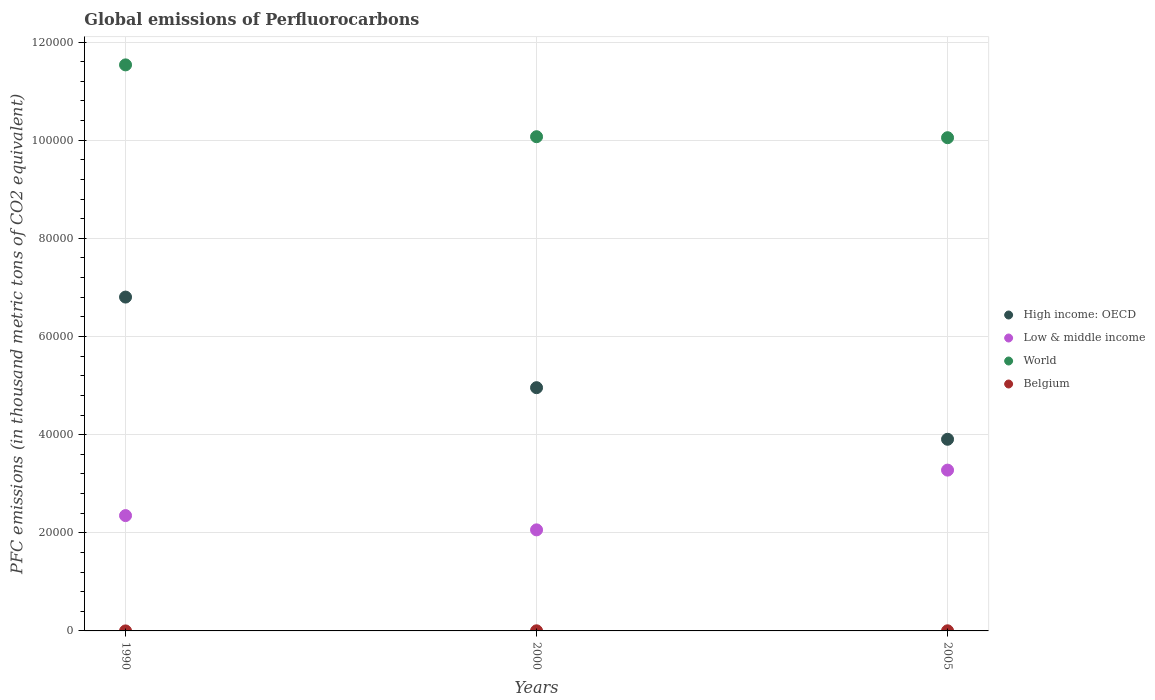How many different coloured dotlines are there?
Offer a terse response. 4. What is the global emissions of Perfluorocarbons in Low & middle income in 1990?
Give a very brief answer. 2.35e+04. Across all years, what is the maximum global emissions of Perfluorocarbons in World?
Your response must be concise. 1.15e+05. Across all years, what is the minimum global emissions of Perfluorocarbons in Belgium?
Keep it short and to the point. 2.9. What is the total global emissions of Perfluorocarbons in Belgium in the graph?
Your answer should be compact. 53.8. What is the difference between the global emissions of Perfluorocarbons in High income: OECD in 1990 and that in 2000?
Provide a succinct answer. 1.85e+04. What is the difference between the global emissions of Perfluorocarbons in World in 1990 and the global emissions of Perfluorocarbons in Belgium in 2000?
Make the answer very short. 1.15e+05. What is the average global emissions of Perfluorocarbons in High income: OECD per year?
Make the answer very short. 5.22e+04. In the year 1990, what is the difference between the global emissions of Perfluorocarbons in High income: OECD and global emissions of Perfluorocarbons in Low & middle income?
Give a very brief answer. 4.45e+04. What is the ratio of the global emissions of Perfluorocarbons in Belgium in 1990 to that in 2000?
Make the answer very short. 0.12. Is the global emissions of Perfluorocarbons in High income: OECD in 1990 less than that in 2000?
Ensure brevity in your answer.  No. What is the difference between the highest and the second highest global emissions of Perfluorocarbons in High income: OECD?
Make the answer very short. 1.85e+04. What is the difference between the highest and the lowest global emissions of Perfluorocarbons in Belgium?
Your response must be concise. 22.8. In how many years, is the global emissions of Perfluorocarbons in Low & middle income greater than the average global emissions of Perfluorocarbons in Low & middle income taken over all years?
Keep it short and to the point. 1. Does the global emissions of Perfluorocarbons in High income: OECD monotonically increase over the years?
Give a very brief answer. No. Is the global emissions of Perfluorocarbons in Low & middle income strictly greater than the global emissions of Perfluorocarbons in Belgium over the years?
Offer a very short reply. Yes. Is the global emissions of Perfluorocarbons in Low & middle income strictly less than the global emissions of Perfluorocarbons in High income: OECD over the years?
Ensure brevity in your answer.  Yes. How many dotlines are there?
Your answer should be compact. 4. How many years are there in the graph?
Keep it short and to the point. 3. What is the difference between two consecutive major ticks on the Y-axis?
Ensure brevity in your answer.  2.00e+04. Are the values on the major ticks of Y-axis written in scientific E-notation?
Give a very brief answer. No. Does the graph contain any zero values?
Provide a succinct answer. No. Where does the legend appear in the graph?
Give a very brief answer. Center right. How are the legend labels stacked?
Your answer should be very brief. Vertical. What is the title of the graph?
Provide a succinct answer. Global emissions of Perfluorocarbons. What is the label or title of the X-axis?
Provide a short and direct response. Years. What is the label or title of the Y-axis?
Offer a very short reply. PFC emissions (in thousand metric tons of CO2 equivalent). What is the PFC emissions (in thousand metric tons of CO2 equivalent) in High income: OECD in 1990?
Offer a terse response. 6.80e+04. What is the PFC emissions (in thousand metric tons of CO2 equivalent) of Low & middle income in 1990?
Provide a succinct answer. 2.35e+04. What is the PFC emissions (in thousand metric tons of CO2 equivalent) in World in 1990?
Offer a very short reply. 1.15e+05. What is the PFC emissions (in thousand metric tons of CO2 equivalent) of High income: OECD in 2000?
Provide a succinct answer. 4.96e+04. What is the PFC emissions (in thousand metric tons of CO2 equivalent) of Low & middle income in 2000?
Your answer should be very brief. 2.06e+04. What is the PFC emissions (in thousand metric tons of CO2 equivalent) in World in 2000?
Your response must be concise. 1.01e+05. What is the PFC emissions (in thousand metric tons of CO2 equivalent) of Belgium in 2000?
Your response must be concise. 25.2. What is the PFC emissions (in thousand metric tons of CO2 equivalent) in High income: OECD in 2005?
Your response must be concise. 3.91e+04. What is the PFC emissions (in thousand metric tons of CO2 equivalent) in Low & middle income in 2005?
Keep it short and to the point. 3.28e+04. What is the PFC emissions (in thousand metric tons of CO2 equivalent) of World in 2005?
Ensure brevity in your answer.  1.01e+05. What is the PFC emissions (in thousand metric tons of CO2 equivalent) in Belgium in 2005?
Provide a short and direct response. 25.7. Across all years, what is the maximum PFC emissions (in thousand metric tons of CO2 equivalent) of High income: OECD?
Provide a short and direct response. 6.80e+04. Across all years, what is the maximum PFC emissions (in thousand metric tons of CO2 equivalent) in Low & middle income?
Ensure brevity in your answer.  3.28e+04. Across all years, what is the maximum PFC emissions (in thousand metric tons of CO2 equivalent) of World?
Offer a very short reply. 1.15e+05. Across all years, what is the maximum PFC emissions (in thousand metric tons of CO2 equivalent) of Belgium?
Offer a terse response. 25.7. Across all years, what is the minimum PFC emissions (in thousand metric tons of CO2 equivalent) in High income: OECD?
Provide a succinct answer. 3.91e+04. Across all years, what is the minimum PFC emissions (in thousand metric tons of CO2 equivalent) in Low & middle income?
Offer a terse response. 2.06e+04. Across all years, what is the minimum PFC emissions (in thousand metric tons of CO2 equivalent) in World?
Keep it short and to the point. 1.01e+05. Across all years, what is the minimum PFC emissions (in thousand metric tons of CO2 equivalent) of Belgium?
Give a very brief answer. 2.9. What is the total PFC emissions (in thousand metric tons of CO2 equivalent) of High income: OECD in the graph?
Make the answer very short. 1.57e+05. What is the total PFC emissions (in thousand metric tons of CO2 equivalent) in Low & middle income in the graph?
Give a very brief answer. 7.69e+04. What is the total PFC emissions (in thousand metric tons of CO2 equivalent) in World in the graph?
Provide a succinct answer. 3.17e+05. What is the total PFC emissions (in thousand metric tons of CO2 equivalent) in Belgium in the graph?
Provide a short and direct response. 53.8. What is the difference between the PFC emissions (in thousand metric tons of CO2 equivalent) in High income: OECD in 1990 and that in 2000?
Your answer should be very brief. 1.85e+04. What is the difference between the PFC emissions (in thousand metric tons of CO2 equivalent) of Low & middle income in 1990 and that in 2000?
Your answer should be very brief. 2906.6. What is the difference between the PFC emissions (in thousand metric tons of CO2 equivalent) in World in 1990 and that in 2000?
Your response must be concise. 1.46e+04. What is the difference between the PFC emissions (in thousand metric tons of CO2 equivalent) of Belgium in 1990 and that in 2000?
Keep it short and to the point. -22.3. What is the difference between the PFC emissions (in thousand metric tons of CO2 equivalent) of High income: OECD in 1990 and that in 2005?
Give a very brief answer. 2.90e+04. What is the difference between the PFC emissions (in thousand metric tons of CO2 equivalent) in Low & middle income in 1990 and that in 2005?
Offer a very short reply. -9268.08. What is the difference between the PFC emissions (in thousand metric tons of CO2 equivalent) of World in 1990 and that in 2005?
Your answer should be very brief. 1.48e+04. What is the difference between the PFC emissions (in thousand metric tons of CO2 equivalent) of Belgium in 1990 and that in 2005?
Offer a terse response. -22.8. What is the difference between the PFC emissions (in thousand metric tons of CO2 equivalent) in High income: OECD in 2000 and that in 2005?
Your answer should be very brief. 1.05e+04. What is the difference between the PFC emissions (in thousand metric tons of CO2 equivalent) in Low & middle income in 2000 and that in 2005?
Ensure brevity in your answer.  -1.22e+04. What is the difference between the PFC emissions (in thousand metric tons of CO2 equivalent) in World in 2000 and that in 2005?
Provide a succinct answer. 203. What is the difference between the PFC emissions (in thousand metric tons of CO2 equivalent) of Belgium in 2000 and that in 2005?
Your response must be concise. -0.5. What is the difference between the PFC emissions (in thousand metric tons of CO2 equivalent) of High income: OECD in 1990 and the PFC emissions (in thousand metric tons of CO2 equivalent) of Low & middle income in 2000?
Make the answer very short. 4.74e+04. What is the difference between the PFC emissions (in thousand metric tons of CO2 equivalent) in High income: OECD in 1990 and the PFC emissions (in thousand metric tons of CO2 equivalent) in World in 2000?
Offer a very short reply. -3.27e+04. What is the difference between the PFC emissions (in thousand metric tons of CO2 equivalent) of High income: OECD in 1990 and the PFC emissions (in thousand metric tons of CO2 equivalent) of Belgium in 2000?
Your answer should be very brief. 6.80e+04. What is the difference between the PFC emissions (in thousand metric tons of CO2 equivalent) of Low & middle income in 1990 and the PFC emissions (in thousand metric tons of CO2 equivalent) of World in 2000?
Offer a very short reply. -7.72e+04. What is the difference between the PFC emissions (in thousand metric tons of CO2 equivalent) of Low & middle income in 1990 and the PFC emissions (in thousand metric tons of CO2 equivalent) of Belgium in 2000?
Offer a terse response. 2.35e+04. What is the difference between the PFC emissions (in thousand metric tons of CO2 equivalent) in World in 1990 and the PFC emissions (in thousand metric tons of CO2 equivalent) in Belgium in 2000?
Keep it short and to the point. 1.15e+05. What is the difference between the PFC emissions (in thousand metric tons of CO2 equivalent) in High income: OECD in 1990 and the PFC emissions (in thousand metric tons of CO2 equivalent) in Low & middle income in 2005?
Your answer should be compact. 3.53e+04. What is the difference between the PFC emissions (in thousand metric tons of CO2 equivalent) in High income: OECD in 1990 and the PFC emissions (in thousand metric tons of CO2 equivalent) in World in 2005?
Provide a short and direct response. -3.25e+04. What is the difference between the PFC emissions (in thousand metric tons of CO2 equivalent) of High income: OECD in 1990 and the PFC emissions (in thousand metric tons of CO2 equivalent) of Belgium in 2005?
Provide a short and direct response. 6.80e+04. What is the difference between the PFC emissions (in thousand metric tons of CO2 equivalent) of Low & middle income in 1990 and the PFC emissions (in thousand metric tons of CO2 equivalent) of World in 2005?
Keep it short and to the point. -7.70e+04. What is the difference between the PFC emissions (in thousand metric tons of CO2 equivalent) of Low & middle income in 1990 and the PFC emissions (in thousand metric tons of CO2 equivalent) of Belgium in 2005?
Provide a succinct answer. 2.35e+04. What is the difference between the PFC emissions (in thousand metric tons of CO2 equivalent) of World in 1990 and the PFC emissions (in thousand metric tons of CO2 equivalent) of Belgium in 2005?
Your response must be concise. 1.15e+05. What is the difference between the PFC emissions (in thousand metric tons of CO2 equivalent) of High income: OECD in 2000 and the PFC emissions (in thousand metric tons of CO2 equivalent) of Low & middle income in 2005?
Provide a succinct answer. 1.68e+04. What is the difference between the PFC emissions (in thousand metric tons of CO2 equivalent) in High income: OECD in 2000 and the PFC emissions (in thousand metric tons of CO2 equivalent) in World in 2005?
Keep it short and to the point. -5.09e+04. What is the difference between the PFC emissions (in thousand metric tons of CO2 equivalent) in High income: OECD in 2000 and the PFC emissions (in thousand metric tons of CO2 equivalent) in Belgium in 2005?
Provide a short and direct response. 4.95e+04. What is the difference between the PFC emissions (in thousand metric tons of CO2 equivalent) in Low & middle income in 2000 and the PFC emissions (in thousand metric tons of CO2 equivalent) in World in 2005?
Ensure brevity in your answer.  -7.99e+04. What is the difference between the PFC emissions (in thousand metric tons of CO2 equivalent) of Low & middle income in 2000 and the PFC emissions (in thousand metric tons of CO2 equivalent) of Belgium in 2005?
Keep it short and to the point. 2.06e+04. What is the difference between the PFC emissions (in thousand metric tons of CO2 equivalent) of World in 2000 and the PFC emissions (in thousand metric tons of CO2 equivalent) of Belgium in 2005?
Make the answer very short. 1.01e+05. What is the average PFC emissions (in thousand metric tons of CO2 equivalent) of High income: OECD per year?
Provide a short and direct response. 5.22e+04. What is the average PFC emissions (in thousand metric tons of CO2 equivalent) of Low & middle income per year?
Make the answer very short. 2.56e+04. What is the average PFC emissions (in thousand metric tons of CO2 equivalent) in World per year?
Make the answer very short. 1.06e+05. What is the average PFC emissions (in thousand metric tons of CO2 equivalent) of Belgium per year?
Offer a very short reply. 17.93. In the year 1990, what is the difference between the PFC emissions (in thousand metric tons of CO2 equivalent) of High income: OECD and PFC emissions (in thousand metric tons of CO2 equivalent) of Low & middle income?
Offer a very short reply. 4.45e+04. In the year 1990, what is the difference between the PFC emissions (in thousand metric tons of CO2 equivalent) in High income: OECD and PFC emissions (in thousand metric tons of CO2 equivalent) in World?
Give a very brief answer. -4.73e+04. In the year 1990, what is the difference between the PFC emissions (in thousand metric tons of CO2 equivalent) of High income: OECD and PFC emissions (in thousand metric tons of CO2 equivalent) of Belgium?
Make the answer very short. 6.80e+04. In the year 1990, what is the difference between the PFC emissions (in thousand metric tons of CO2 equivalent) of Low & middle income and PFC emissions (in thousand metric tons of CO2 equivalent) of World?
Your answer should be very brief. -9.19e+04. In the year 1990, what is the difference between the PFC emissions (in thousand metric tons of CO2 equivalent) in Low & middle income and PFC emissions (in thousand metric tons of CO2 equivalent) in Belgium?
Offer a terse response. 2.35e+04. In the year 1990, what is the difference between the PFC emissions (in thousand metric tons of CO2 equivalent) of World and PFC emissions (in thousand metric tons of CO2 equivalent) of Belgium?
Give a very brief answer. 1.15e+05. In the year 2000, what is the difference between the PFC emissions (in thousand metric tons of CO2 equivalent) in High income: OECD and PFC emissions (in thousand metric tons of CO2 equivalent) in Low & middle income?
Your response must be concise. 2.90e+04. In the year 2000, what is the difference between the PFC emissions (in thousand metric tons of CO2 equivalent) of High income: OECD and PFC emissions (in thousand metric tons of CO2 equivalent) of World?
Keep it short and to the point. -5.11e+04. In the year 2000, what is the difference between the PFC emissions (in thousand metric tons of CO2 equivalent) in High income: OECD and PFC emissions (in thousand metric tons of CO2 equivalent) in Belgium?
Ensure brevity in your answer.  4.95e+04. In the year 2000, what is the difference between the PFC emissions (in thousand metric tons of CO2 equivalent) of Low & middle income and PFC emissions (in thousand metric tons of CO2 equivalent) of World?
Your answer should be compact. -8.01e+04. In the year 2000, what is the difference between the PFC emissions (in thousand metric tons of CO2 equivalent) of Low & middle income and PFC emissions (in thousand metric tons of CO2 equivalent) of Belgium?
Offer a very short reply. 2.06e+04. In the year 2000, what is the difference between the PFC emissions (in thousand metric tons of CO2 equivalent) of World and PFC emissions (in thousand metric tons of CO2 equivalent) of Belgium?
Provide a succinct answer. 1.01e+05. In the year 2005, what is the difference between the PFC emissions (in thousand metric tons of CO2 equivalent) in High income: OECD and PFC emissions (in thousand metric tons of CO2 equivalent) in Low & middle income?
Keep it short and to the point. 6287.52. In the year 2005, what is the difference between the PFC emissions (in thousand metric tons of CO2 equivalent) in High income: OECD and PFC emissions (in thousand metric tons of CO2 equivalent) in World?
Give a very brief answer. -6.15e+04. In the year 2005, what is the difference between the PFC emissions (in thousand metric tons of CO2 equivalent) in High income: OECD and PFC emissions (in thousand metric tons of CO2 equivalent) in Belgium?
Make the answer very short. 3.90e+04. In the year 2005, what is the difference between the PFC emissions (in thousand metric tons of CO2 equivalent) of Low & middle income and PFC emissions (in thousand metric tons of CO2 equivalent) of World?
Give a very brief answer. -6.77e+04. In the year 2005, what is the difference between the PFC emissions (in thousand metric tons of CO2 equivalent) in Low & middle income and PFC emissions (in thousand metric tons of CO2 equivalent) in Belgium?
Offer a very short reply. 3.27e+04. In the year 2005, what is the difference between the PFC emissions (in thousand metric tons of CO2 equivalent) in World and PFC emissions (in thousand metric tons of CO2 equivalent) in Belgium?
Your answer should be very brief. 1.00e+05. What is the ratio of the PFC emissions (in thousand metric tons of CO2 equivalent) in High income: OECD in 1990 to that in 2000?
Your answer should be compact. 1.37. What is the ratio of the PFC emissions (in thousand metric tons of CO2 equivalent) of Low & middle income in 1990 to that in 2000?
Give a very brief answer. 1.14. What is the ratio of the PFC emissions (in thousand metric tons of CO2 equivalent) of World in 1990 to that in 2000?
Keep it short and to the point. 1.15. What is the ratio of the PFC emissions (in thousand metric tons of CO2 equivalent) of Belgium in 1990 to that in 2000?
Ensure brevity in your answer.  0.12. What is the ratio of the PFC emissions (in thousand metric tons of CO2 equivalent) in High income: OECD in 1990 to that in 2005?
Your answer should be compact. 1.74. What is the ratio of the PFC emissions (in thousand metric tons of CO2 equivalent) in Low & middle income in 1990 to that in 2005?
Ensure brevity in your answer.  0.72. What is the ratio of the PFC emissions (in thousand metric tons of CO2 equivalent) of World in 1990 to that in 2005?
Ensure brevity in your answer.  1.15. What is the ratio of the PFC emissions (in thousand metric tons of CO2 equivalent) in Belgium in 1990 to that in 2005?
Keep it short and to the point. 0.11. What is the ratio of the PFC emissions (in thousand metric tons of CO2 equivalent) of High income: OECD in 2000 to that in 2005?
Your response must be concise. 1.27. What is the ratio of the PFC emissions (in thousand metric tons of CO2 equivalent) of Low & middle income in 2000 to that in 2005?
Keep it short and to the point. 0.63. What is the ratio of the PFC emissions (in thousand metric tons of CO2 equivalent) in World in 2000 to that in 2005?
Offer a terse response. 1. What is the ratio of the PFC emissions (in thousand metric tons of CO2 equivalent) of Belgium in 2000 to that in 2005?
Keep it short and to the point. 0.98. What is the difference between the highest and the second highest PFC emissions (in thousand metric tons of CO2 equivalent) of High income: OECD?
Provide a succinct answer. 1.85e+04. What is the difference between the highest and the second highest PFC emissions (in thousand metric tons of CO2 equivalent) in Low & middle income?
Your response must be concise. 9268.08. What is the difference between the highest and the second highest PFC emissions (in thousand metric tons of CO2 equivalent) in World?
Your response must be concise. 1.46e+04. What is the difference between the highest and the second highest PFC emissions (in thousand metric tons of CO2 equivalent) in Belgium?
Provide a short and direct response. 0.5. What is the difference between the highest and the lowest PFC emissions (in thousand metric tons of CO2 equivalent) in High income: OECD?
Your answer should be compact. 2.90e+04. What is the difference between the highest and the lowest PFC emissions (in thousand metric tons of CO2 equivalent) of Low & middle income?
Your answer should be very brief. 1.22e+04. What is the difference between the highest and the lowest PFC emissions (in thousand metric tons of CO2 equivalent) in World?
Give a very brief answer. 1.48e+04. What is the difference between the highest and the lowest PFC emissions (in thousand metric tons of CO2 equivalent) in Belgium?
Ensure brevity in your answer.  22.8. 